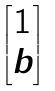Convert formula to latex. <formula><loc_0><loc_0><loc_500><loc_500>\begin{bmatrix} 1 \\ b \end{bmatrix}</formula> 